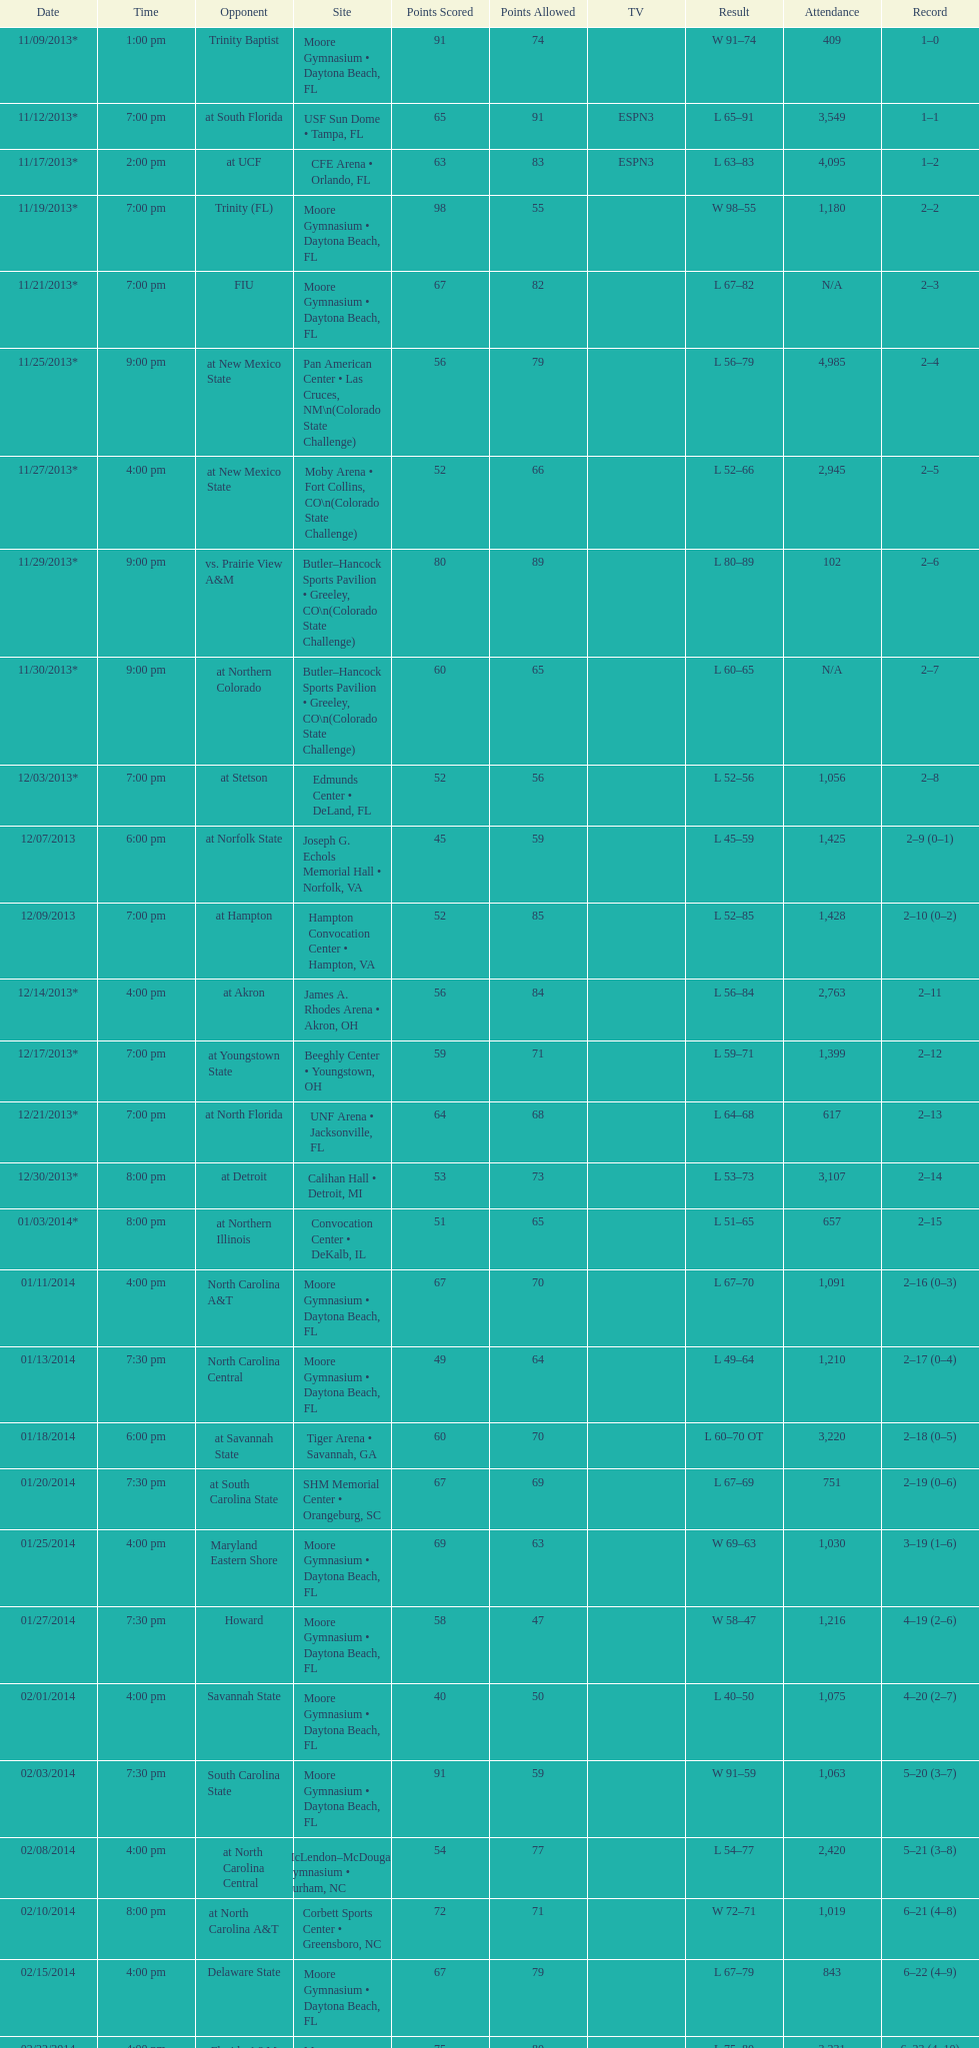Was the attendance of the game held on 11/19/2013 greater than 1,000? Yes. 